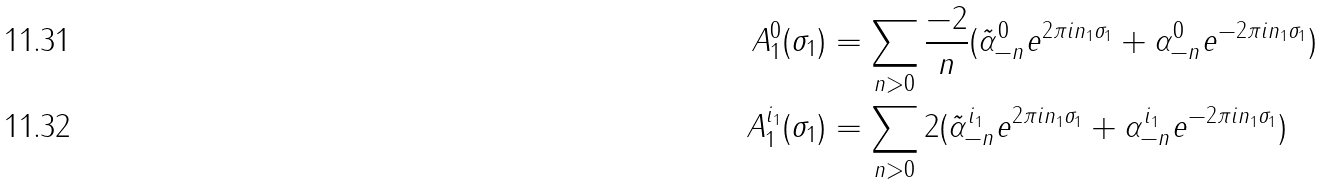Convert formula to latex. <formula><loc_0><loc_0><loc_500><loc_500>A ^ { 0 } _ { 1 } ( \sigma _ { 1 } ) & = \sum _ { n > 0 } \frac { - 2 } { n } ( \tilde { \alpha } ^ { 0 } _ { - n } e ^ { 2 \pi i n _ { 1 } \sigma _ { 1 } } + \alpha ^ { 0 } _ { - n } e ^ { - 2 \pi i n _ { 1 } \sigma _ { 1 } } ) \\ A ^ { i _ { 1 } } _ { 1 } ( \sigma _ { 1 } ) & = \sum _ { n > 0 } 2 ( \tilde { \alpha } ^ { i _ { 1 } } _ { - n } e ^ { 2 \pi i n _ { 1 } \sigma _ { 1 } } + \alpha ^ { i _ { 1 } } _ { - n } e ^ { - 2 \pi i n _ { 1 } \sigma _ { 1 } } )</formula> 